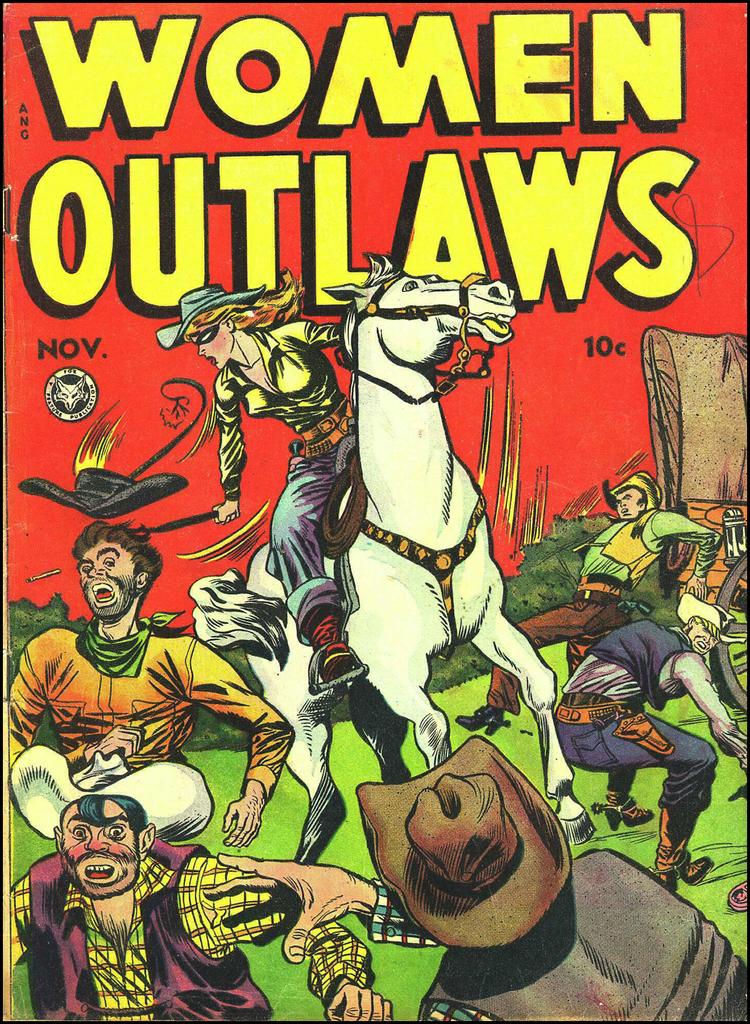Which month is this showing?
Keep it short and to the point. November. 